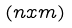<formula> <loc_0><loc_0><loc_500><loc_500>( n x m )</formula> 